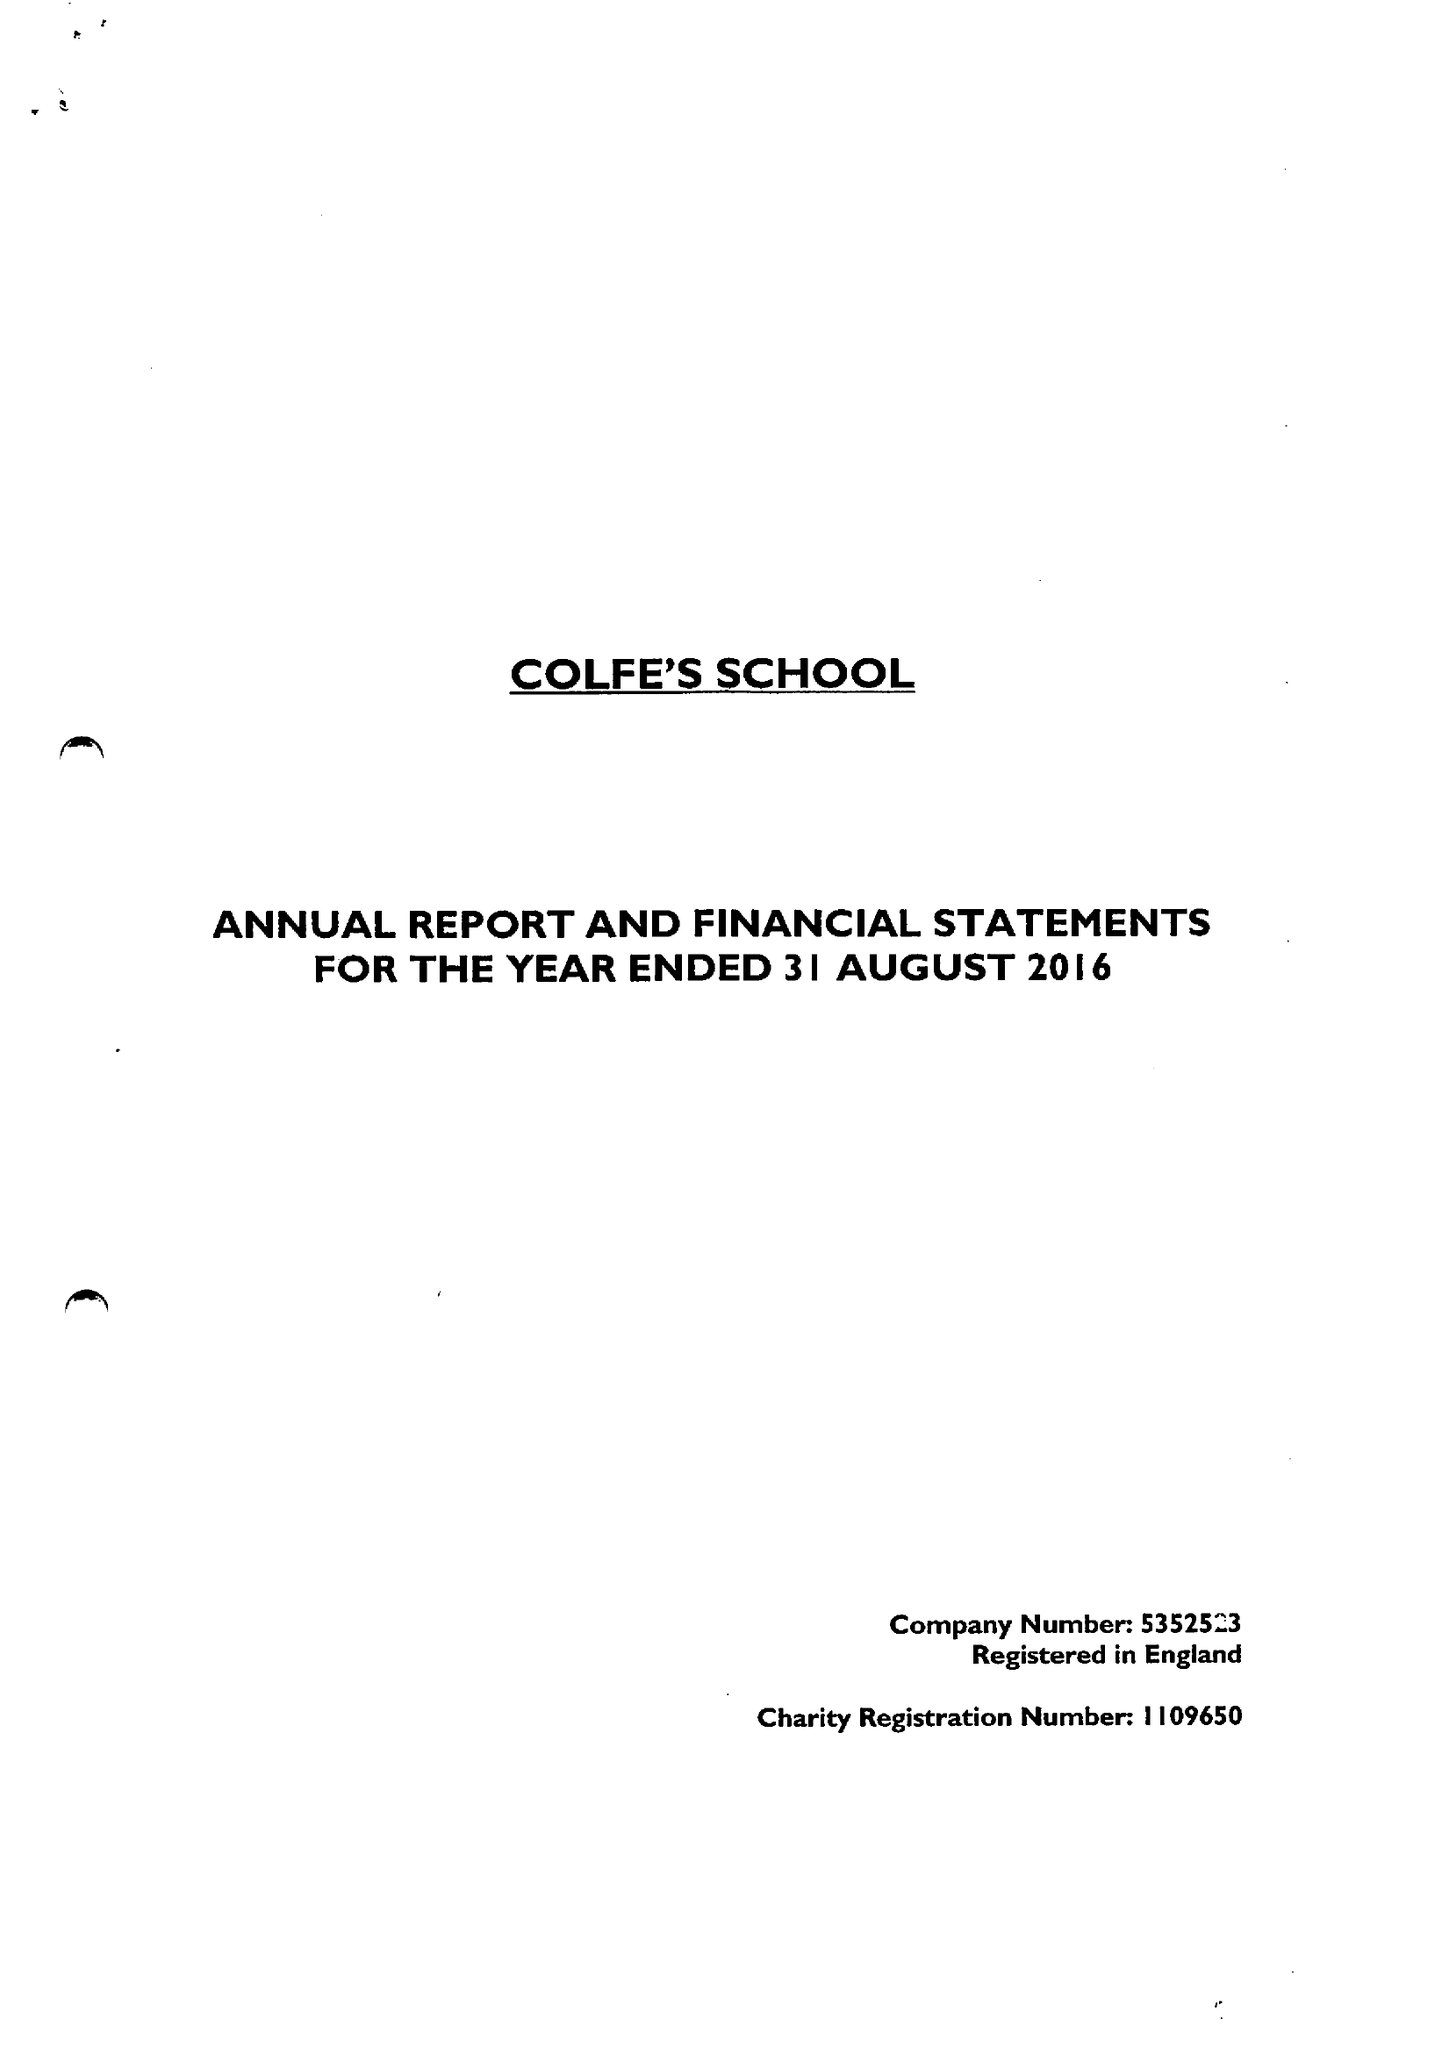What is the value for the charity_number?
Answer the question using a single word or phrase. 1109650 